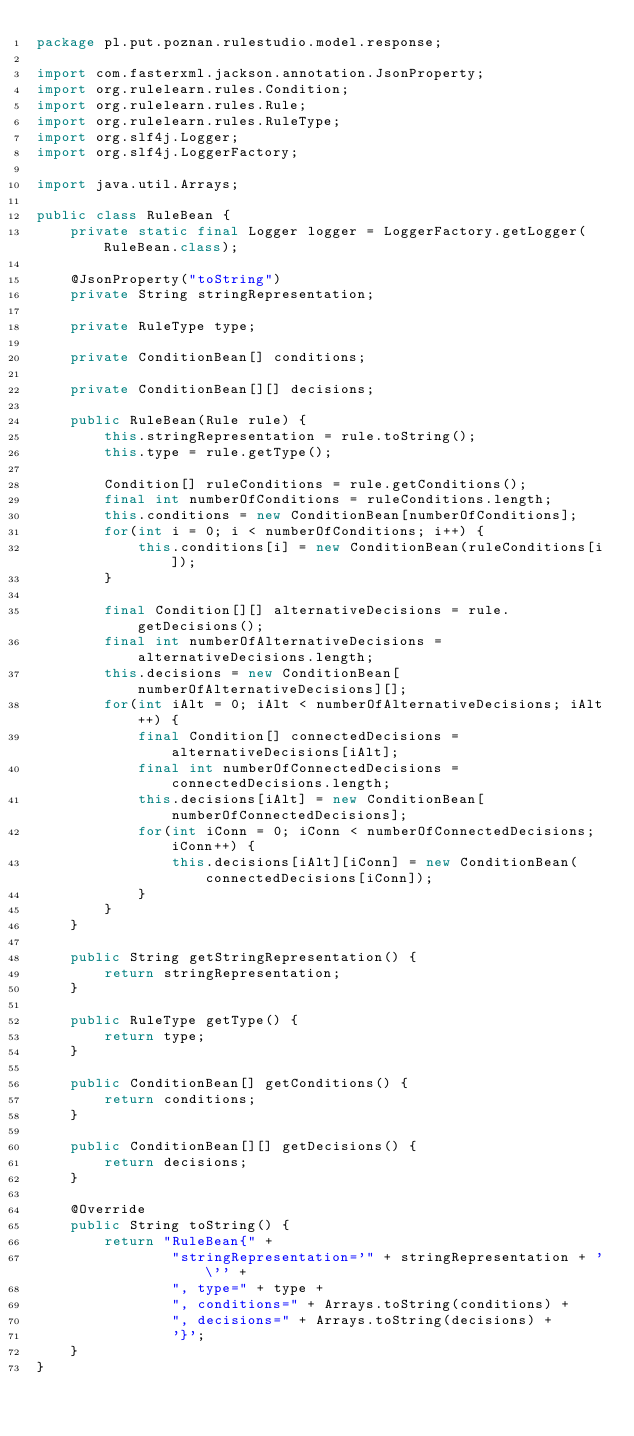<code> <loc_0><loc_0><loc_500><loc_500><_Java_>package pl.put.poznan.rulestudio.model.response;

import com.fasterxml.jackson.annotation.JsonProperty;
import org.rulelearn.rules.Condition;
import org.rulelearn.rules.Rule;
import org.rulelearn.rules.RuleType;
import org.slf4j.Logger;
import org.slf4j.LoggerFactory;

import java.util.Arrays;

public class RuleBean {
    private static final Logger logger = LoggerFactory.getLogger(RuleBean.class);

    @JsonProperty("toString")
    private String stringRepresentation;

    private RuleType type;

    private ConditionBean[] conditions;

    private ConditionBean[][] decisions;

    public RuleBean(Rule rule) {
        this.stringRepresentation = rule.toString();
        this.type = rule.getType();

        Condition[] ruleConditions = rule.getConditions();
        final int numberOfConditions = ruleConditions.length;
        this.conditions = new ConditionBean[numberOfConditions];
        for(int i = 0; i < numberOfConditions; i++) {
            this.conditions[i] = new ConditionBean(ruleConditions[i]);
        }

        final Condition[][] alternativeDecisions = rule.getDecisions();
        final int numberOfAlternativeDecisions = alternativeDecisions.length;
        this.decisions = new ConditionBean[numberOfAlternativeDecisions][];
        for(int iAlt = 0; iAlt < numberOfAlternativeDecisions; iAlt++) {
            final Condition[] connectedDecisions = alternativeDecisions[iAlt];
            final int numberOfConnectedDecisions = connectedDecisions.length;
            this.decisions[iAlt] = new ConditionBean[numberOfConnectedDecisions];
            for(int iConn = 0; iConn < numberOfConnectedDecisions; iConn++) {
                this.decisions[iAlt][iConn] = new ConditionBean(connectedDecisions[iConn]);
            }
        }
    }

    public String getStringRepresentation() {
        return stringRepresentation;
    }

    public RuleType getType() {
        return type;
    }

    public ConditionBean[] getConditions() {
        return conditions;
    }

    public ConditionBean[][] getDecisions() {
        return decisions;
    }

    @Override
    public String toString() {
        return "RuleBean{" +
                "stringRepresentation='" + stringRepresentation + '\'' +
                ", type=" + type +
                ", conditions=" + Arrays.toString(conditions) +
                ", decisions=" + Arrays.toString(decisions) +
                '}';
    }
}
</code> 